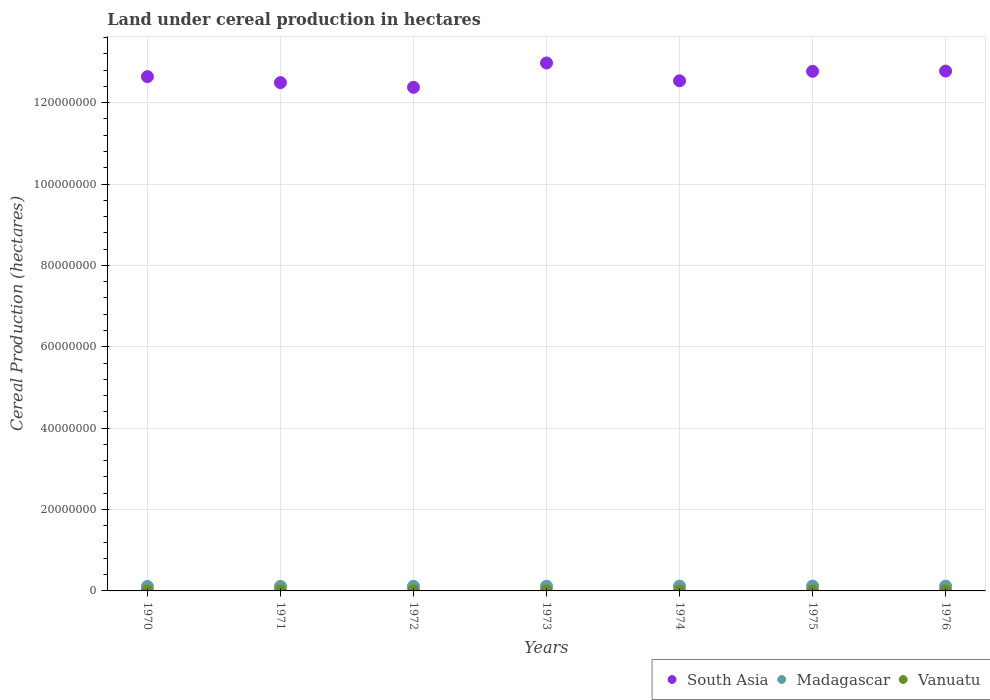What is the land under cereal production in South Asia in 1974?
Provide a short and direct response. 1.25e+08. Across all years, what is the maximum land under cereal production in South Asia?
Make the answer very short. 1.30e+08. Across all years, what is the minimum land under cereal production in Madagascar?
Ensure brevity in your answer.  1.11e+06. In which year was the land under cereal production in Madagascar maximum?
Give a very brief answer. 1975. In which year was the land under cereal production in Madagascar minimum?
Keep it short and to the point. 1970. What is the total land under cereal production in Vanuatu in the graph?
Keep it short and to the point. 7000. What is the difference between the land under cereal production in Madagascar in 1971 and that in 1973?
Keep it short and to the point. -4.00e+04. What is the difference between the land under cereal production in South Asia in 1973 and the land under cereal production in Madagascar in 1971?
Keep it short and to the point. 1.29e+08. What is the average land under cereal production in South Asia per year?
Make the answer very short. 1.27e+08. In the year 1975, what is the difference between the land under cereal production in Vanuatu and land under cereal production in Madagascar?
Offer a terse response. -1.19e+06. What is the ratio of the land under cereal production in Madagascar in 1972 to that in 1973?
Ensure brevity in your answer.  0.97. Is the land under cereal production in Vanuatu in 1971 less than that in 1976?
Offer a terse response. Yes. Is the difference between the land under cereal production in Vanuatu in 1970 and 1974 greater than the difference between the land under cereal production in Madagascar in 1970 and 1974?
Your answer should be compact. Yes. What is the difference between the highest and the second highest land under cereal production in Madagascar?
Your answer should be compact. 1.10e+04. What is the difference between the highest and the lowest land under cereal production in Madagascar?
Your response must be concise. 8.34e+04. In how many years, is the land under cereal production in Madagascar greater than the average land under cereal production in Madagascar taken over all years?
Keep it short and to the point. 4. Is the sum of the land under cereal production in Madagascar in 1972 and 1976 greater than the maximum land under cereal production in Vanuatu across all years?
Your answer should be compact. Yes. Is the land under cereal production in Vanuatu strictly greater than the land under cereal production in Madagascar over the years?
Your answer should be compact. No. How many dotlines are there?
Your answer should be compact. 3. How many years are there in the graph?
Offer a terse response. 7. What is the difference between two consecutive major ticks on the Y-axis?
Your answer should be compact. 2.00e+07. Are the values on the major ticks of Y-axis written in scientific E-notation?
Provide a succinct answer. No. Does the graph contain any zero values?
Provide a short and direct response. No. Where does the legend appear in the graph?
Your answer should be very brief. Bottom right. How many legend labels are there?
Your response must be concise. 3. How are the legend labels stacked?
Your answer should be very brief. Horizontal. What is the title of the graph?
Your answer should be compact. Land under cereal production in hectares. What is the label or title of the X-axis?
Your response must be concise. Years. What is the label or title of the Y-axis?
Ensure brevity in your answer.  Cereal Production (hectares). What is the Cereal Production (hectares) of South Asia in 1970?
Keep it short and to the point. 1.26e+08. What is the Cereal Production (hectares) of Madagascar in 1970?
Give a very brief answer. 1.11e+06. What is the Cereal Production (hectares) in Vanuatu in 1970?
Ensure brevity in your answer.  850. What is the Cereal Production (hectares) in South Asia in 1971?
Provide a succinct answer. 1.25e+08. What is the Cereal Production (hectares) in Madagascar in 1971?
Make the answer very short. 1.12e+06. What is the Cereal Production (hectares) in Vanuatu in 1971?
Your response must be concise. 900. What is the Cereal Production (hectares) of South Asia in 1972?
Offer a very short reply. 1.24e+08. What is the Cereal Production (hectares) in Madagascar in 1972?
Keep it short and to the point. 1.13e+06. What is the Cereal Production (hectares) of Vanuatu in 1972?
Offer a terse response. 950. What is the Cereal Production (hectares) of South Asia in 1973?
Keep it short and to the point. 1.30e+08. What is the Cereal Production (hectares) of Madagascar in 1973?
Keep it short and to the point. 1.16e+06. What is the Cereal Production (hectares) in Vanuatu in 1973?
Your answer should be very brief. 1000. What is the Cereal Production (hectares) of South Asia in 1974?
Your answer should be compact. 1.25e+08. What is the Cereal Production (hectares) in Madagascar in 1974?
Provide a short and direct response. 1.18e+06. What is the Cereal Production (hectares) in Vanuatu in 1974?
Offer a very short reply. 1000. What is the Cereal Production (hectares) of South Asia in 1975?
Provide a short and direct response. 1.28e+08. What is the Cereal Production (hectares) of Madagascar in 1975?
Make the answer very short. 1.19e+06. What is the Cereal Production (hectares) in Vanuatu in 1975?
Give a very brief answer. 1100. What is the Cereal Production (hectares) of South Asia in 1976?
Provide a short and direct response. 1.28e+08. What is the Cereal Production (hectares) of Madagascar in 1976?
Your answer should be compact. 1.18e+06. What is the Cereal Production (hectares) of Vanuatu in 1976?
Offer a very short reply. 1200. Across all years, what is the maximum Cereal Production (hectares) in South Asia?
Keep it short and to the point. 1.30e+08. Across all years, what is the maximum Cereal Production (hectares) in Madagascar?
Make the answer very short. 1.19e+06. Across all years, what is the maximum Cereal Production (hectares) of Vanuatu?
Provide a short and direct response. 1200. Across all years, what is the minimum Cereal Production (hectares) of South Asia?
Make the answer very short. 1.24e+08. Across all years, what is the minimum Cereal Production (hectares) in Madagascar?
Provide a short and direct response. 1.11e+06. Across all years, what is the minimum Cereal Production (hectares) in Vanuatu?
Make the answer very short. 850. What is the total Cereal Production (hectares) of South Asia in the graph?
Offer a very short reply. 8.86e+08. What is the total Cereal Production (hectares) of Madagascar in the graph?
Keep it short and to the point. 8.07e+06. What is the total Cereal Production (hectares) of Vanuatu in the graph?
Make the answer very short. 7000. What is the difference between the Cereal Production (hectares) of South Asia in 1970 and that in 1971?
Make the answer very short. 1.47e+06. What is the difference between the Cereal Production (hectares) in Madagascar in 1970 and that in 1971?
Your response must be concise. -1.37e+04. What is the difference between the Cereal Production (hectares) of South Asia in 1970 and that in 1972?
Make the answer very short. 2.62e+06. What is the difference between the Cereal Production (hectares) in Madagascar in 1970 and that in 1972?
Your answer should be very brief. -2.37e+04. What is the difference between the Cereal Production (hectares) in Vanuatu in 1970 and that in 1972?
Provide a short and direct response. -100. What is the difference between the Cereal Production (hectares) of South Asia in 1970 and that in 1973?
Make the answer very short. -3.36e+06. What is the difference between the Cereal Production (hectares) of Madagascar in 1970 and that in 1973?
Provide a succinct answer. -5.37e+04. What is the difference between the Cereal Production (hectares) in Vanuatu in 1970 and that in 1973?
Provide a succinct answer. -150. What is the difference between the Cereal Production (hectares) of South Asia in 1970 and that in 1974?
Ensure brevity in your answer.  1.02e+06. What is the difference between the Cereal Production (hectares) in Madagascar in 1970 and that in 1974?
Provide a succinct answer. -7.19e+04. What is the difference between the Cereal Production (hectares) in Vanuatu in 1970 and that in 1974?
Offer a very short reply. -150. What is the difference between the Cereal Production (hectares) in South Asia in 1970 and that in 1975?
Make the answer very short. -1.31e+06. What is the difference between the Cereal Production (hectares) in Madagascar in 1970 and that in 1975?
Your answer should be very brief. -8.34e+04. What is the difference between the Cereal Production (hectares) in Vanuatu in 1970 and that in 1975?
Your answer should be compact. -250. What is the difference between the Cereal Production (hectares) in South Asia in 1970 and that in 1976?
Keep it short and to the point. -1.37e+06. What is the difference between the Cereal Production (hectares) in Madagascar in 1970 and that in 1976?
Offer a terse response. -7.25e+04. What is the difference between the Cereal Production (hectares) of Vanuatu in 1970 and that in 1976?
Provide a short and direct response. -350. What is the difference between the Cereal Production (hectares) of South Asia in 1971 and that in 1972?
Ensure brevity in your answer.  1.15e+06. What is the difference between the Cereal Production (hectares) in Madagascar in 1971 and that in 1972?
Make the answer very short. -1.00e+04. What is the difference between the Cereal Production (hectares) of Vanuatu in 1971 and that in 1972?
Your answer should be compact. -50. What is the difference between the Cereal Production (hectares) in South Asia in 1971 and that in 1973?
Your answer should be very brief. -4.83e+06. What is the difference between the Cereal Production (hectares) of Madagascar in 1971 and that in 1973?
Your response must be concise. -4.00e+04. What is the difference between the Cereal Production (hectares) of Vanuatu in 1971 and that in 1973?
Give a very brief answer. -100. What is the difference between the Cereal Production (hectares) of South Asia in 1971 and that in 1974?
Offer a terse response. -4.54e+05. What is the difference between the Cereal Production (hectares) of Madagascar in 1971 and that in 1974?
Provide a short and direct response. -5.82e+04. What is the difference between the Cereal Production (hectares) of Vanuatu in 1971 and that in 1974?
Your answer should be compact. -100. What is the difference between the Cereal Production (hectares) in South Asia in 1971 and that in 1975?
Provide a succinct answer. -2.79e+06. What is the difference between the Cereal Production (hectares) in Madagascar in 1971 and that in 1975?
Make the answer very short. -6.98e+04. What is the difference between the Cereal Production (hectares) in Vanuatu in 1971 and that in 1975?
Give a very brief answer. -200. What is the difference between the Cereal Production (hectares) of South Asia in 1971 and that in 1976?
Your answer should be very brief. -2.84e+06. What is the difference between the Cereal Production (hectares) of Madagascar in 1971 and that in 1976?
Your answer should be very brief. -5.88e+04. What is the difference between the Cereal Production (hectares) in Vanuatu in 1971 and that in 1976?
Your answer should be compact. -300. What is the difference between the Cereal Production (hectares) in South Asia in 1972 and that in 1973?
Your answer should be compact. -5.98e+06. What is the difference between the Cereal Production (hectares) in Madagascar in 1972 and that in 1973?
Provide a short and direct response. -3.00e+04. What is the difference between the Cereal Production (hectares) in South Asia in 1972 and that in 1974?
Provide a succinct answer. -1.60e+06. What is the difference between the Cereal Production (hectares) of Madagascar in 1972 and that in 1974?
Make the answer very short. -4.82e+04. What is the difference between the Cereal Production (hectares) in South Asia in 1972 and that in 1975?
Offer a very short reply. -3.94e+06. What is the difference between the Cereal Production (hectares) of Madagascar in 1972 and that in 1975?
Provide a short and direct response. -5.98e+04. What is the difference between the Cereal Production (hectares) of Vanuatu in 1972 and that in 1975?
Provide a short and direct response. -150. What is the difference between the Cereal Production (hectares) of South Asia in 1972 and that in 1976?
Keep it short and to the point. -3.99e+06. What is the difference between the Cereal Production (hectares) in Madagascar in 1972 and that in 1976?
Offer a terse response. -4.88e+04. What is the difference between the Cereal Production (hectares) of Vanuatu in 1972 and that in 1976?
Your response must be concise. -250. What is the difference between the Cereal Production (hectares) of South Asia in 1973 and that in 1974?
Provide a short and direct response. 4.38e+06. What is the difference between the Cereal Production (hectares) of Madagascar in 1973 and that in 1974?
Provide a succinct answer. -1.82e+04. What is the difference between the Cereal Production (hectares) of Vanuatu in 1973 and that in 1974?
Your response must be concise. 0. What is the difference between the Cereal Production (hectares) of South Asia in 1973 and that in 1975?
Ensure brevity in your answer.  2.05e+06. What is the difference between the Cereal Production (hectares) of Madagascar in 1973 and that in 1975?
Your response must be concise. -2.97e+04. What is the difference between the Cereal Production (hectares) in Vanuatu in 1973 and that in 1975?
Make the answer very short. -100. What is the difference between the Cereal Production (hectares) in South Asia in 1973 and that in 1976?
Provide a short and direct response. 1.99e+06. What is the difference between the Cereal Production (hectares) in Madagascar in 1973 and that in 1976?
Make the answer very short. -1.87e+04. What is the difference between the Cereal Production (hectares) in Vanuatu in 1973 and that in 1976?
Your answer should be compact. -200. What is the difference between the Cereal Production (hectares) in South Asia in 1974 and that in 1975?
Keep it short and to the point. -2.33e+06. What is the difference between the Cereal Production (hectares) in Madagascar in 1974 and that in 1975?
Provide a succinct answer. -1.16e+04. What is the difference between the Cereal Production (hectares) of Vanuatu in 1974 and that in 1975?
Ensure brevity in your answer.  -100. What is the difference between the Cereal Production (hectares) of South Asia in 1974 and that in 1976?
Give a very brief answer. -2.39e+06. What is the difference between the Cereal Production (hectares) in Madagascar in 1974 and that in 1976?
Ensure brevity in your answer.  -594. What is the difference between the Cereal Production (hectares) of Vanuatu in 1974 and that in 1976?
Offer a very short reply. -200. What is the difference between the Cereal Production (hectares) in South Asia in 1975 and that in 1976?
Ensure brevity in your answer.  -5.33e+04. What is the difference between the Cereal Production (hectares) of Madagascar in 1975 and that in 1976?
Offer a very short reply. 1.10e+04. What is the difference between the Cereal Production (hectares) in Vanuatu in 1975 and that in 1976?
Give a very brief answer. -100. What is the difference between the Cereal Production (hectares) in South Asia in 1970 and the Cereal Production (hectares) in Madagascar in 1971?
Your answer should be very brief. 1.25e+08. What is the difference between the Cereal Production (hectares) of South Asia in 1970 and the Cereal Production (hectares) of Vanuatu in 1971?
Provide a short and direct response. 1.26e+08. What is the difference between the Cereal Production (hectares) in Madagascar in 1970 and the Cereal Production (hectares) in Vanuatu in 1971?
Provide a succinct answer. 1.11e+06. What is the difference between the Cereal Production (hectares) of South Asia in 1970 and the Cereal Production (hectares) of Madagascar in 1972?
Offer a very short reply. 1.25e+08. What is the difference between the Cereal Production (hectares) in South Asia in 1970 and the Cereal Production (hectares) in Vanuatu in 1972?
Provide a short and direct response. 1.26e+08. What is the difference between the Cereal Production (hectares) in Madagascar in 1970 and the Cereal Production (hectares) in Vanuatu in 1972?
Your answer should be compact. 1.11e+06. What is the difference between the Cereal Production (hectares) of South Asia in 1970 and the Cereal Production (hectares) of Madagascar in 1973?
Your answer should be compact. 1.25e+08. What is the difference between the Cereal Production (hectares) of South Asia in 1970 and the Cereal Production (hectares) of Vanuatu in 1973?
Make the answer very short. 1.26e+08. What is the difference between the Cereal Production (hectares) of Madagascar in 1970 and the Cereal Production (hectares) of Vanuatu in 1973?
Offer a very short reply. 1.11e+06. What is the difference between the Cereal Production (hectares) of South Asia in 1970 and the Cereal Production (hectares) of Madagascar in 1974?
Keep it short and to the point. 1.25e+08. What is the difference between the Cereal Production (hectares) in South Asia in 1970 and the Cereal Production (hectares) in Vanuatu in 1974?
Your answer should be very brief. 1.26e+08. What is the difference between the Cereal Production (hectares) in Madagascar in 1970 and the Cereal Production (hectares) in Vanuatu in 1974?
Ensure brevity in your answer.  1.11e+06. What is the difference between the Cereal Production (hectares) in South Asia in 1970 and the Cereal Production (hectares) in Madagascar in 1975?
Offer a very short reply. 1.25e+08. What is the difference between the Cereal Production (hectares) in South Asia in 1970 and the Cereal Production (hectares) in Vanuatu in 1975?
Give a very brief answer. 1.26e+08. What is the difference between the Cereal Production (hectares) in Madagascar in 1970 and the Cereal Production (hectares) in Vanuatu in 1975?
Your answer should be very brief. 1.11e+06. What is the difference between the Cereal Production (hectares) in South Asia in 1970 and the Cereal Production (hectares) in Madagascar in 1976?
Offer a very short reply. 1.25e+08. What is the difference between the Cereal Production (hectares) in South Asia in 1970 and the Cereal Production (hectares) in Vanuatu in 1976?
Offer a very short reply. 1.26e+08. What is the difference between the Cereal Production (hectares) in Madagascar in 1970 and the Cereal Production (hectares) in Vanuatu in 1976?
Provide a succinct answer. 1.11e+06. What is the difference between the Cereal Production (hectares) of South Asia in 1971 and the Cereal Production (hectares) of Madagascar in 1972?
Offer a very short reply. 1.24e+08. What is the difference between the Cereal Production (hectares) in South Asia in 1971 and the Cereal Production (hectares) in Vanuatu in 1972?
Your response must be concise. 1.25e+08. What is the difference between the Cereal Production (hectares) in Madagascar in 1971 and the Cereal Production (hectares) in Vanuatu in 1972?
Provide a short and direct response. 1.12e+06. What is the difference between the Cereal Production (hectares) of South Asia in 1971 and the Cereal Production (hectares) of Madagascar in 1973?
Provide a short and direct response. 1.24e+08. What is the difference between the Cereal Production (hectares) of South Asia in 1971 and the Cereal Production (hectares) of Vanuatu in 1973?
Ensure brevity in your answer.  1.25e+08. What is the difference between the Cereal Production (hectares) in Madagascar in 1971 and the Cereal Production (hectares) in Vanuatu in 1973?
Keep it short and to the point. 1.12e+06. What is the difference between the Cereal Production (hectares) in South Asia in 1971 and the Cereal Production (hectares) in Madagascar in 1974?
Provide a short and direct response. 1.24e+08. What is the difference between the Cereal Production (hectares) in South Asia in 1971 and the Cereal Production (hectares) in Vanuatu in 1974?
Offer a terse response. 1.25e+08. What is the difference between the Cereal Production (hectares) of Madagascar in 1971 and the Cereal Production (hectares) of Vanuatu in 1974?
Your response must be concise. 1.12e+06. What is the difference between the Cereal Production (hectares) in South Asia in 1971 and the Cereal Production (hectares) in Madagascar in 1975?
Keep it short and to the point. 1.24e+08. What is the difference between the Cereal Production (hectares) in South Asia in 1971 and the Cereal Production (hectares) in Vanuatu in 1975?
Your response must be concise. 1.25e+08. What is the difference between the Cereal Production (hectares) of Madagascar in 1971 and the Cereal Production (hectares) of Vanuatu in 1975?
Ensure brevity in your answer.  1.12e+06. What is the difference between the Cereal Production (hectares) in South Asia in 1971 and the Cereal Production (hectares) in Madagascar in 1976?
Offer a terse response. 1.24e+08. What is the difference between the Cereal Production (hectares) of South Asia in 1971 and the Cereal Production (hectares) of Vanuatu in 1976?
Offer a terse response. 1.25e+08. What is the difference between the Cereal Production (hectares) of Madagascar in 1971 and the Cereal Production (hectares) of Vanuatu in 1976?
Your response must be concise. 1.12e+06. What is the difference between the Cereal Production (hectares) of South Asia in 1972 and the Cereal Production (hectares) of Madagascar in 1973?
Ensure brevity in your answer.  1.23e+08. What is the difference between the Cereal Production (hectares) in South Asia in 1972 and the Cereal Production (hectares) in Vanuatu in 1973?
Give a very brief answer. 1.24e+08. What is the difference between the Cereal Production (hectares) of Madagascar in 1972 and the Cereal Production (hectares) of Vanuatu in 1973?
Offer a terse response. 1.13e+06. What is the difference between the Cereal Production (hectares) of South Asia in 1972 and the Cereal Production (hectares) of Madagascar in 1974?
Make the answer very short. 1.23e+08. What is the difference between the Cereal Production (hectares) in South Asia in 1972 and the Cereal Production (hectares) in Vanuatu in 1974?
Provide a short and direct response. 1.24e+08. What is the difference between the Cereal Production (hectares) of Madagascar in 1972 and the Cereal Production (hectares) of Vanuatu in 1974?
Give a very brief answer. 1.13e+06. What is the difference between the Cereal Production (hectares) of South Asia in 1972 and the Cereal Production (hectares) of Madagascar in 1975?
Your answer should be compact. 1.23e+08. What is the difference between the Cereal Production (hectares) in South Asia in 1972 and the Cereal Production (hectares) in Vanuatu in 1975?
Your answer should be compact. 1.24e+08. What is the difference between the Cereal Production (hectares) in Madagascar in 1972 and the Cereal Production (hectares) in Vanuatu in 1975?
Offer a very short reply. 1.13e+06. What is the difference between the Cereal Production (hectares) in South Asia in 1972 and the Cereal Production (hectares) in Madagascar in 1976?
Offer a terse response. 1.23e+08. What is the difference between the Cereal Production (hectares) in South Asia in 1972 and the Cereal Production (hectares) in Vanuatu in 1976?
Keep it short and to the point. 1.24e+08. What is the difference between the Cereal Production (hectares) of Madagascar in 1972 and the Cereal Production (hectares) of Vanuatu in 1976?
Your answer should be compact. 1.13e+06. What is the difference between the Cereal Production (hectares) of South Asia in 1973 and the Cereal Production (hectares) of Madagascar in 1974?
Offer a terse response. 1.29e+08. What is the difference between the Cereal Production (hectares) of South Asia in 1973 and the Cereal Production (hectares) of Vanuatu in 1974?
Make the answer very short. 1.30e+08. What is the difference between the Cereal Production (hectares) in Madagascar in 1973 and the Cereal Production (hectares) in Vanuatu in 1974?
Provide a succinct answer. 1.16e+06. What is the difference between the Cereal Production (hectares) of South Asia in 1973 and the Cereal Production (hectares) of Madagascar in 1975?
Keep it short and to the point. 1.29e+08. What is the difference between the Cereal Production (hectares) of South Asia in 1973 and the Cereal Production (hectares) of Vanuatu in 1975?
Ensure brevity in your answer.  1.30e+08. What is the difference between the Cereal Production (hectares) of Madagascar in 1973 and the Cereal Production (hectares) of Vanuatu in 1975?
Give a very brief answer. 1.16e+06. What is the difference between the Cereal Production (hectares) of South Asia in 1973 and the Cereal Production (hectares) of Madagascar in 1976?
Give a very brief answer. 1.29e+08. What is the difference between the Cereal Production (hectares) of South Asia in 1973 and the Cereal Production (hectares) of Vanuatu in 1976?
Provide a succinct answer. 1.30e+08. What is the difference between the Cereal Production (hectares) in Madagascar in 1973 and the Cereal Production (hectares) in Vanuatu in 1976?
Offer a very short reply. 1.16e+06. What is the difference between the Cereal Production (hectares) of South Asia in 1974 and the Cereal Production (hectares) of Madagascar in 1975?
Keep it short and to the point. 1.24e+08. What is the difference between the Cereal Production (hectares) of South Asia in 1974 and the Cereal Production (hectares) of Vanuatu in 1975?
Offer a very short reply. 1.25e+08. What is the difference between the Cereal Production (hectares) of Madagascar in 1974 and the Cereal Production (hectares) of Vanuatu in 1975?
Ensure brevity in your answer.  1.18e+06. What is the difference between the Cereal Production (hectares) of South Asia in 1974 and the Cereal Production (hectares) of Madagascar in 1976?
Provide a short and direct response. 1.24e+08. What is the difference between the Cereal Production (hectares) in South Asia in 1974 and the Cereal Production (hectares) in Vanuatu in 1976?
Provide a short and direct response. 1.25e+08. What is the difference between the Cereal Production (hectares) of Madagascar in 1974 and the Cereal Production (hectares) of Vanuatu in 1976?
Provide a short and direct response. 1.18e+06. What is the difference between the Cereal Production (hectares) in South Asia in 1975 and the Cereal Production (hectares) in Madagascar in 1976?
Ensure brevity in your answer.  1.27e+08. What is the difference between the Cereal Production (hectares) of South Asia in 1975 and the Cereal Production (hectares) of Vanuatu in 1976?
Your response must be concise. 1.28e+08. What is the difference between the Cereal Production (hectares) of Madagascar in 1975 and the Cereal Production (hectares) of Vanuatu in 1976?
Your answer should be compact. 1.19e+06. What is the average Cereal Production (hectares) of South Asia per year?
Provide a short and direct response. 1.27e+08. What is the average Cereal Production (hectares) in Madagascar per year?
Provide a short and direct response. 1.15e+06. In the year 1970, what is the difference between the Cereal Production (hectares) of South Asia and Cereal Production (hectares) of Madagascar?
Keep it short and to the point. 1.25e+08. In the year 1970, what is the difference between the Cereal Production (hectares) in South Asia and Cereal Production (hectares) in Vanuatu?
Your answer should be compact. 1.26e+08. In the year 1970, what is the difference between the Cereal Production (hectares) in Madagascar and Cereal Production (hectares) in Vanuatu?
Make the answer very short. 1.11e+06. In the year 1971, what is the difference between the Cereal Production (hectares) of South Asia and Cereal Production (hectares) of Madagascar?
Keep it short and to the point. 1.24e+08. In the year 1971, what is the difference between the Cereal Production (hectares) in South Asia and Cereal Production (hectares) in Vanuatu?
Keep it short and to the point. 1.25e+08. In the year 1971, what is the difference between the Cereal Production (hectares) in Madagascar and Cereal Production (hectares) in Vanuatu?
Give a very brief answer. 1.12e+06. In the year 1972, what is the difference between the Cereal Production (hectares) of South Asia and Cereal Production (hectares) of Madagascar?
Keep it short and to the point. 1.23e+08. In the year 1972, what is the difference between the Cereal Production (hectares) of South Asia and Cereal Production (hectares) of Vanuatu?
Ensure brevity in your answer.  1.24e+08. In the year 1972, what is the difference between the Cereal Production (hectares) in Madagascar and Cereal Production (hectares) in Vanuatu?
Make the answer very short. 1.13e+06. In the year 1973, what is the difference between the Cereal Production (hectares) in South Asia and Cereal Production (hectares) in Madagascar?
Offer a very short reply. 1.29e+08. In the year 1973, what is the difference between the Cereal Production (hectares) in South Asia and Cereal Production (hectares) in Vanuatu?
Offer a terse response. 1.30e+08. In the year 1973, what is the difference between the Cereal Production (hectares) of Madagascar and Cereal Production (hectares) of Vanuatu?
Your response must be concise. 1.16e+06. In the year 1974, what is the difference between the Cereal Production (hectares) of South Asia and Cereal Production (hectares) of Madagascar?
Offer a very short reply. 1.24e+08. In the year 1974, what is the difference between the Cereal Production (hectares) of South Asia and Cereal Production (hectares) of Vanuatu?
Your answer should be very brief. 1.25e+08. In the year 1974, what is the difference between the Cereal Production (hectares) of Madagascar and Cereal Production (hectares) of Vanuatu?
Offer a terse response. 1.18e+06. In the year 1975, what is the difference between the Cereal Production (hectares) in South Asia and Cereal Production (hectares) in Madagascar?
Keep it short and to the point. 1.27e+08. In the year 1975, what is the difference between the Cereal Production (hectares) of South Asia and Cereal Production (hectares) of Vanuatu?
Provide a succinct answer. 1.28e+08. In the year 1975, what is the difference between the Cereal Production (hectares) in Madagascar and Cereal Production (hectares) in Vanuatu?
Your answer should be very brief. 1.19e+06. In the year 1976, what is the difference between the Cereal Production (hectares) of South Asia and Cereal Production (hectares) of Madagascar?
Ensure brevity in your answer.  1.27e+08. In the year 1976, what is the difference between the Cereal Production (hectares) of South Asia and Cereal Production (hectares) of Vanuatu?
Keep it short and to the point. 1.28e+08. In the year 1976, what is the difference between the Cereal Production (hectares) in Madagascar and Cereal Production (hectares) in Vanuatu?
Keep it short and to the point. 1.18e+06. What is the ratio of the Cereal Production (hectares) in South Asia in 1970 to that in 1971?
Your response must be concise. 1.01. What is the ratio of the Cereal Production (hectares) of Madagascar in 1970 to that in 1971?
Keep it short and to the point. 0.99. What is the ratio of the Cereal Production (hectares) in Vanuatu in 1970 to that in 1971?
Keep it short and to the point. 0.94. What is the ratio of the Cereal Production (hectares) of South Asia in 1970 to that in 1972?
Your response must be concise. 1.02. What is the ratio of the Cereal Production (hectares) of Madagascar in 1970 to that in 1972?
Make the answer very short. 0.98. What is the ratio of the Cereal Production (hectares) of Vanuatu in 1970 to that in 1972?
Your response must be concise. 0.89. What is the ratio of the Cereal Production (hectares) of South Asia in 1970 to that in 1973?
Your answer should be very brief. 0.97. What is the ratio of the Cereal Production (hectares) in Madagascar in 1970 to that in 1973?
Your answer should be compact. 0.95. What is the ratio of the Cereal Production (hectares) of Vanuatu in 1970 to that in 1973?
Keep it short and to the point. 0.85. What is the ratio of the Cereal Production (hectares) of Madagascar in 1970 to that in 1974?
Provide a short and direct response. 0.94. What is the ratio of the Cereal Production (hectares) of South Asia in 1970 to that in 1975?
Ensure brevity in your answer.  0.99. What is the ratio of the Cereal Production (hectares) of Madagascar in 1970 to that in 1975?
Provide a succinct answer. 0.93. What is the ratio of the Cereal Production (hectares) of Vanuatu in 1970 to that in 1975?
Your answer should be compact. 0.77. What is the ratio of the Cereal Production (hectares) in South Asia in 1970 to that in 1976?
Offer a terse response. 0.99. What is the ratio of the Cereal Production (hectares) of Madagascar in 1970 to that in 1976?
Give a very brief answer. 0.94. What is the ratio of the Cereal Production (hectares) in Vanuatu in 1970 to that in 1976?
Make the answer very short. 0.71. What is the ratio of the Cereal Production (hectares) of South Asia in 1971 to that in 1972?
Your answer should be very brief. 1.01. What is the ratio of the Cereal Production (hectares) in Madagascar in 1971 to that in 1972?
Give a very brief answer. 0.99. What is the ratio of the Cereal Production (hectares) in Vanuatu in 1971 to that in 1972?
Offer a very short reply. 0.95. What is the ratio of the Cereal Production (hectares) in South Asia in 1971 to that in 1973?
Provide a succinct answer. 0.96. What is the ratio of the Cereal Production (hectares) in Madagascar in 1971 to that in 1973?
Offer a terse response. 0.97. What is the ratio of the Cereal Production (hectares) of Madagascar in 1971 to that in 1974?
Provide a succinct answer. 0.95. What is the ratio of the Cereal Production (hectares) in Vanuatu in 1971 to that in 1974?
Give a very brief answer. 0.9. What is the ratio of the Cereal Production (hectares) of South Asia in 1971 to that in 1975?
Provide a short and direct response. 0.98. What is the ratio of the Cereal Production (hectares) of Madagascar in 1971 to that in 1975?
Ensure brevity in your answer.  0.94. What is the ratio of the Cereal Production (hectares) of Vanuatu in 1971 to that in 1975?
Give a very brief answer. 0.82. What is the ratio of the Cereal Production (hectares) of South Asia in 1971 to that in 1976?
Make the answer very short. 0.98. What is the ratio of the Cereal Production (hectares) of Madagascar in 1971 to that in 1976?
Provide a succinct answer. 0.95. What is the ratio of the Cereal Production (hectares) of South Asia in 1972 to that in 1973?
Offer a very short reply. 0.95. What is the ratio of the Cereal Production (hectares) in Madagascar in 1972 to that in 1973?
Offer a terse response. 0.97. What is the ratio of the Cereal Production (hectares) in Vanuatu in 1972 to that in 1973?
Offer a terse response. 0.95. What is the ratio of the Cereal Production (hectares) of South Asia in 1972 to that in 1974?
Your answer should be very brief. 0.99. What is the ratio of the Cereal Production (hectares) in Madagascar in 1972 to that in 1974?
Your answer should be very brief. 0.96. What is the ratio of the Cereal Production (hectares) in South Asia in 1972 to that in 1975?
Your answer should be compact. 0.97. What is the ratio of the Cereal Production (hectares) of Madagascar in 1972 to that in 1975?
Give a very brief answer. 0.95. What is the ratio of the Cereal Production (hectares) of Vanuatu in 1972 to that in 1975?
Your response must be concise. 0.86. What is the ratio of the Cereal Production (hectares) in South Asia in 1972 to that in 1976?
Offer a very short reply. 0.97. What is the ratio of the Cereal Production (hectares) of Madagascar in 1972 to that in 1976?
Keep it short and to the point. 0.96. What is the ratio of the Cereal Production (hectares) in Vanuatu in 1972 to that in 1976?
Offer a terse response. 0.79. What is the ratio of the Cereal Production (hectares) in South Asia in 1973 to that in 1974?
Provide a short and direct response. 1.03. What is the ratio of the Cereal Production (hectares) in Madagascar in 1973 to that in 1974?
Your response must be concise. 0.98. What is the ratio of the Cereal Production (hectares) of Vanuatu in 1973 to that in 1975?
Provide a succinct answer. 0.91. What is the ratio of the Cereal Production (hectares) of South Asia in 1973 to that in 1976?
Make the answer very short. 1.02. What is the ratio of the Cereal Production (hectares) in Madagascar in 1973 to that in 1976?
Give a very brief answer. 0.98. What is the ratio of the Cereal Production (hectares) of Vanuatu in 1973 to that in 1976?
Give a very brief answer. 0.83. What is the ratio of the Cereal Production (hectares) of South Asia in 1974 to that in 1975?
Provide a succinct answer. 0.98. What is the ratio of the Cereal Production (hectares) of Madagascar in 1974 to that in 1975?
Your answer should be very brief. 0.99. What is the ratio of the Cereal Production (hectares) in South Asia in 1974 to that in 1976?
Give a very brief answer. 0.98. What is the ratio of the Cereal Production (hectares) in South Asia in 1975 to that in 1976?
Ensure brevity in your answer.  1. What is the ratio of the Cereal Production (hectares) of Madagascar in 1975 to that in 1976?
Give a very brief answer. 1.01. What is the ratio of the Cereal Production (hectares) of Vanuatu in 1975 to that in 1976?
Your answer should be very brief. 0.92. What is the difference between the highest and the second highest Cereal Production (hectares) in South Asia?
Keep it short and to the point. 1.99e+06. What is the difference between the highest and the second highest Cereal Production (hectares) in Madagascar?
Your response must be concise. 1.10e+04. What is the difference between the highest and the lowest Cereal Production (hectares) in South Asia?
Give a very brief answer. 5.98e+06. What is the difference between the highest and the lowest Cereal Production (hectares) in Madagascar?
Provide a succinct answer. 8.34e+04. What is the difference between the highest and the lowest Cereal Production (hectares) of Vanuatu?
Provide a short and direct response. 350. 